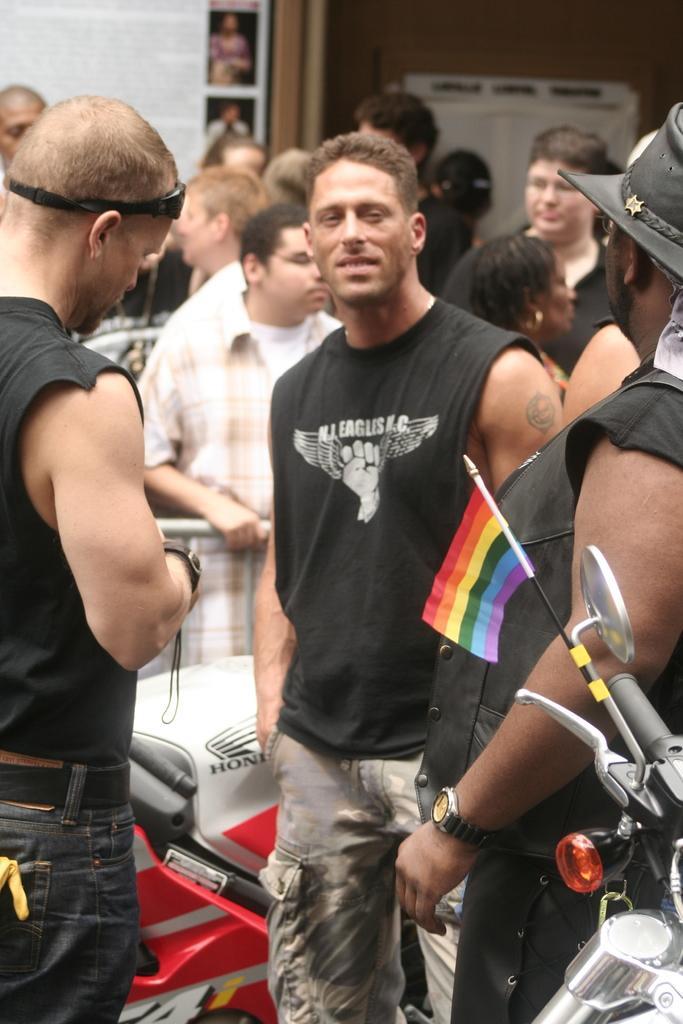Could you give a brief overview of what you see in this image? In this image I can see the group of people with different color dresses. I can see one person with the hat. I can see the motorbikes. In the background I can see few objects and the wall. 